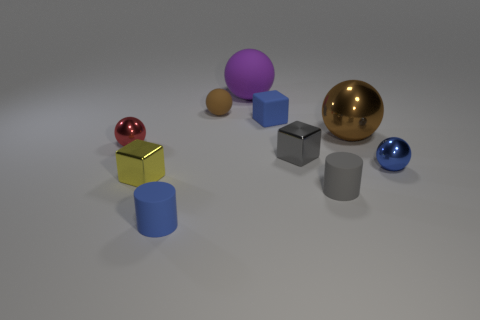There is a gray cube; is its size the same as the blue object that is in front of the yellow object?
Give a very brief answer. Yes. How many objects are either gray objects or big metallic balls?
Ensure brevity in your answer.  3. How many other objects are the same size as the brown metallic thing?
Your answer should be very brief. 1. Does the rubber block have the same color as the small metal sphere left of the small yellow object?
Offer a terse response. No. What number of cubes are large things or brown rubber objects?
Ensure brevity in your answer.  0. Is there anything else that has the same color as the tiny matte block?
Give a very brief answer. Yes. What is the material of the tiny cylinder that is behind the blue matte thing in front of the tiny red ball?
Make the answer very short. Rubber. Does the blue cylinder have the same material as the big sphere that is to the left of the large brown metallic ball?
Offer a very short reply. Yes. What number of things are either tiny spheres that are in front of the red ball or gray metallic blocks?
Make the answer very short. 2. Is there a large matte cube of the same color as the large metal sphere?
Your answer should be compact. No. 